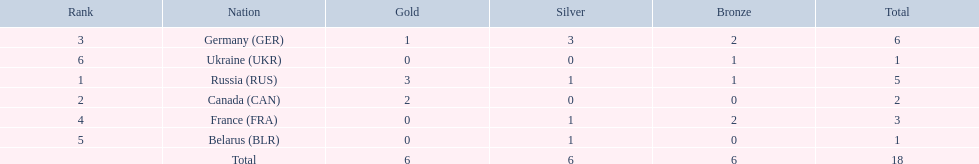What country only received gold medals in the 1994 winter olympics biathlon? Canada (CAN). I'm looking to parse the entire table for insights. Could you assist me with that? {'header': ['Rank', 'Nation', 'Gold', 'Silver', 'Bronze', 'Total'], 'rows': [['3', 'Germany\xa0(GER)', '1', '3', '2', '6'], ['6', 'Ukraine\xa0(UKR)', '0', '0', '1', '1'], ['1', 'Russia\xa0(RUS)', '3', '1', '1', '5'], ['2', 'Canada\xa0(CAN)', '2', '0', '0', '2'], ['4', 'France\xa0(FRA)', '0', '1', '2', '3'], ['5', 'Belarus\xa0(BLR)', '0', '1', '0', '1'], ['', 'Total', '6', '6', '6', '18']]} 